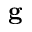<formula> <loc_0><loc_0><loc_500><loc_500>g</formula> 